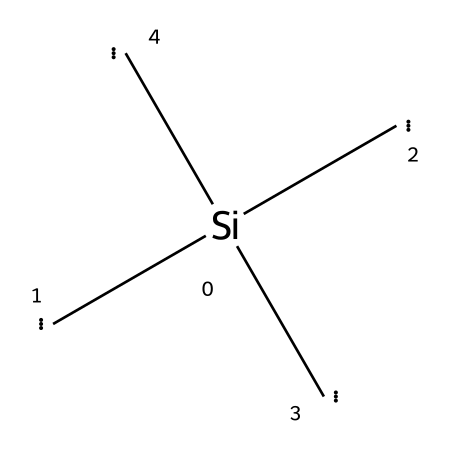How many carbon atoms are in this chemical? There are three carbon atoms connected to the silicon atom in the structure. Each bracketed [C] represents an individual carbon atom, leading to a total count of three.
Answer: three What is the main chemical component of this structure? The main component is silicon, represented by the [Si] at the center of the structure. This indicates that silicon is the primary element around which the others are arranged.
Answer: silicon How many covalent bonds are present in this chemical structure? The structure contains four covalent bonds: one from silicon to each of the three carbon atoms and one between the silicon and itself, forming a tetrahedral geometry typical for silicon compounds.
Answer: four What type of crystal structure does silicon carbide typically form? Silicon carbide typically forms a hexagonal crystal structure, resulting from the arrangement of silicon and carbon in alternating layers.
Answer: hexagonal Is the chemical structure likely to be stable? Yes, the arrangement of silicon and carbon in this structure tends to be stable due to the strong covalent bonds formed between silicon and carbon atoms, characteristic of silicon carbide.
Answer: yes What does the presence of multiple carbon atoms suggest about the compound? The presence of multiple carbon atoms suggests that this compound may have enhanced properties such as increased hardness or strength, which is relevant for applications such as alien armor in sci-fi contexts.
Answer: enhanced properties 